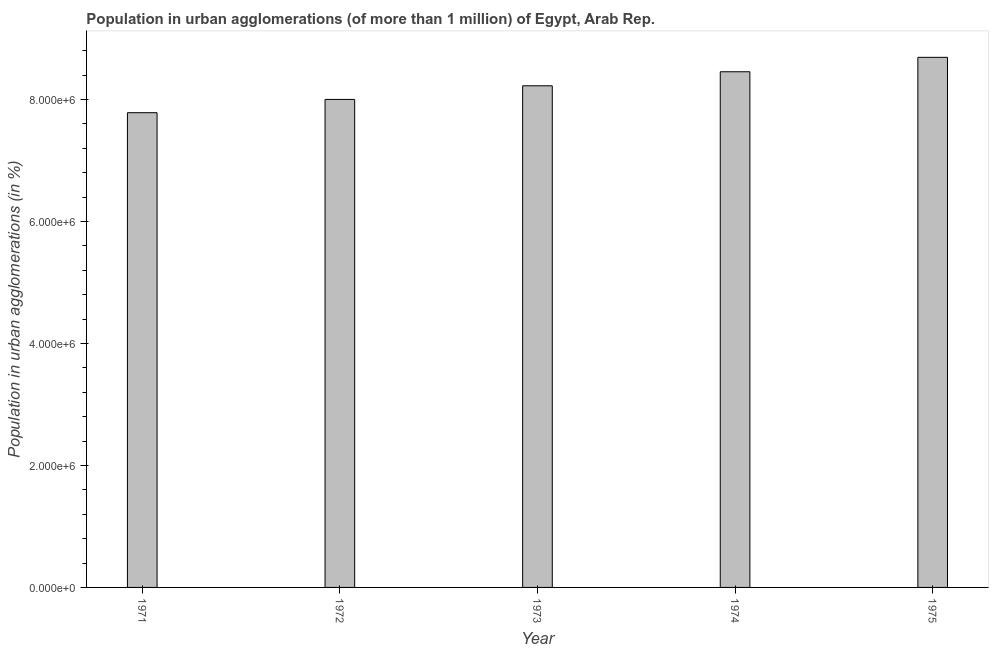Does the graph contain grids?
Ensure brevity in your answer.  No. What is the title of the graph?
Your answer should be compact. Population in urban agglomerations (of more than 1 million) of Egypt, Arab Rep. What is the label or title of the Y-axis?
Provide a short and direct response. Population in urban agglomerations (in %). What is the population in urban agglomerations in 1975?
Offer a very short reply. 8.69e+06. Across all years, what is the maximum population in urban agglomerations?
Make the answer very short. 8.69e+06. Across all years, what is the minimum population in urban agglomerations?
Provide a succinct answer. 7.78e+06. In which year was the population in urban agglomerations maximum?
Offer a terse response. 1975. In which year was the population in urban agglomerations minimum?
Offer a very short reply. 1971. What is the sum of the population in urban agglomerations?
Provide a succinct answer. 4.12e+07. What is the difference between the population in urban agglomerations in 1972 and 1973?
Your answer should be very brief. -2.23e+05. What is the average population in urban agglomerations per year?
Offer a terse response. 8.23e+06. What is the median population in urban agglomerations?
Keep it short and to the point. 8.22e+06. Is the difference between the population in urban agglomerations in 1972 and 1974 greater than the difference between any two years?
Your answer should be very brief. No. What is the difference between the highest and the second highest population in urban agglomerations?
Offer a very short reply. 2.36e+05. What is the difference between the highest and the lowest population in urban agglomerations?
Provide a succinct answer. 9.08e+05. In how many years, is the population in urban agglomerations greater than the average population in urban agglomerations taken over all years?
Offer a very short reply. 2. Are all the bars in the graph horizontal?
Provide a succinct answer. No. What is the difference between two consecutive major ticks on the Y-axis?
Your response must be concise. 2.00e+06. Are the values on the major ticks of Y-axis written in scientific E-notation?
Give a very brief answer. Yes. What is the Population in urban agglomerations (in %) of 1971?
Ensure brevity in your answer.  7.78e+06. What is the Population in urban agglomerations (in %) in 1972?
Provide a short and direct response. 8.00e+06. What is the Population in urban agglomerations (in %) of 1973?
Offer a very short reply. 8.22e+06. What is the Population in urban agglomerations (in %) in 1974?
Keep it short and to the point. 8.45e+06. What is the Population in urban agglomerations (in %) in 1975?
Keep it short and to the point. 8.69e+06. What is the difference between the Population in urban agglomerations (in %) in 1971 and 1972?
Ensure brevity in your answer.  -2.18e+05. What is the difference between the Population in urban agglomerations (in %) in 1971 and 1973?
Give a very brief answer. -4.41e+05. What is the difference between the Population in urban agglomerations (in %) in 1971 and 1974?
Make the answer very short. -6.71e+05. What is the difference between the Population in urban agglomerations (in %) in 1971 and 1975?
Offer a terse response. -9.08e+05. What is the difference between the Population in urban agglomerations (in %) in 1972 and 1973?
Your response must be concise. -2.23e+05. What is the difference between the Population in urban agglomerations (in %) in 1972 and 1974?
Your response must be concise. -4.53e+05. What is the difference between the Population in urban agglomerations (in %) in 1972 and 1975?
Your answer should be compact. -6.90e+05. What is the difference between the Population in urban agglomerations (in %) in 1973 and 1974?
Your answer should be very brief. -2.30e+05. What is the difference between the Population in urban agglomerations (in %) in 1973 and 1975?
Keep it short and to the point. -4.66e+05. What is the difference between the Population in urban agglomerations (in %) in 1974 and 1975?
Your response must be concise. -2.36e+05. What is the ratio of the Population in urban agglomerations (in %) in 1971 to that in 1972?
Give a very brief answer. 0.97. What is the ratio of the Population in urban agglomerations (in %) in 1971 to that in 1973?
Keep it short and to the point. 0.95. What is the ratio of the Population in urban agglomerations (in %) in 1971 to that in 1974?
Provide a succinct answer. 0.92. What is the ratio of the Population in urban agglomerations (in %) in 1971 to that in 1975?
Your answer should be compact. 0.9. What is the ratio of the Population in urban agglomerations (in %) in 1972 to that in 1973?
Provide a succinct answer. 0.97. What is the ratio of the Population in urban agglomerations (in %) in 1972 to that in 1974?
Make the answer very short. 0.95. What is the ratio of the Population in urban agglomerations (in %) in 1972 to that in 1975?
Give a very brief answer. 0.92. What is the ratio of the Population in urban agglomerations (in %) in 1973 to that in 1975?
Offer a terse response. 0.95. 